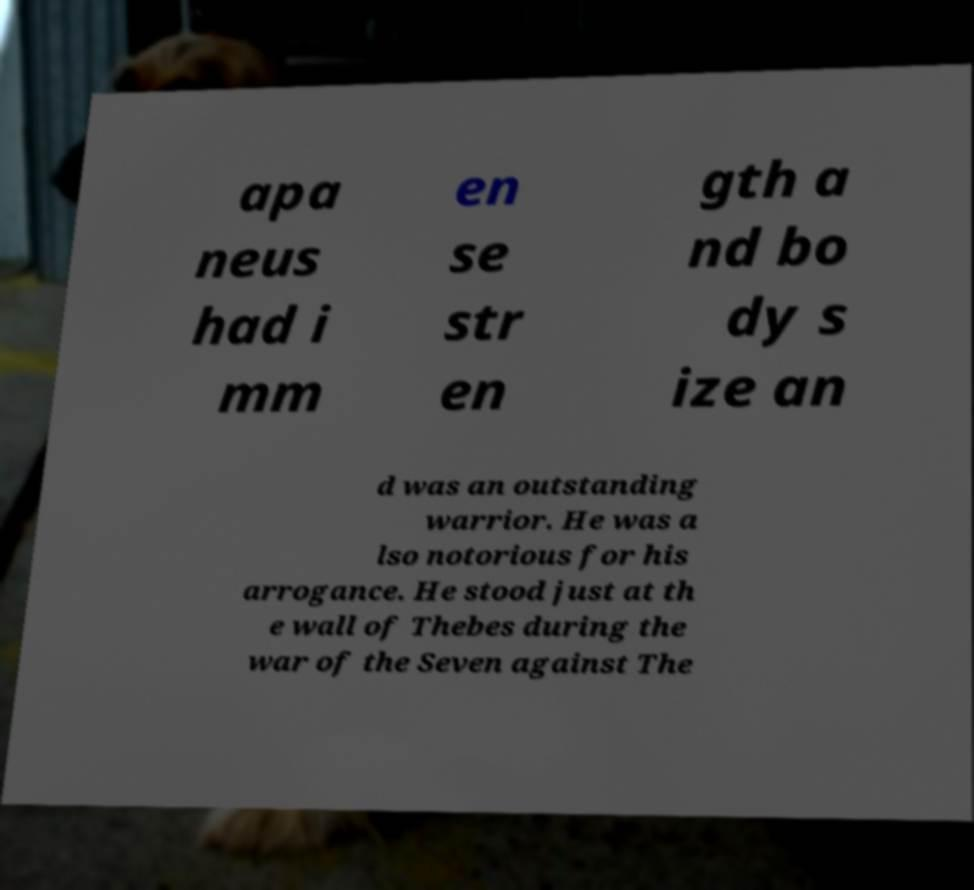Please read and relay the text visible in this image. What does it say? apa neus had i mm en se str en gth a nd bo dy s ize an d was an outstanding warrior. He was a lso notorious for his arrogance. He stood just at th e wall of Thebes during the war of the Seven against The 